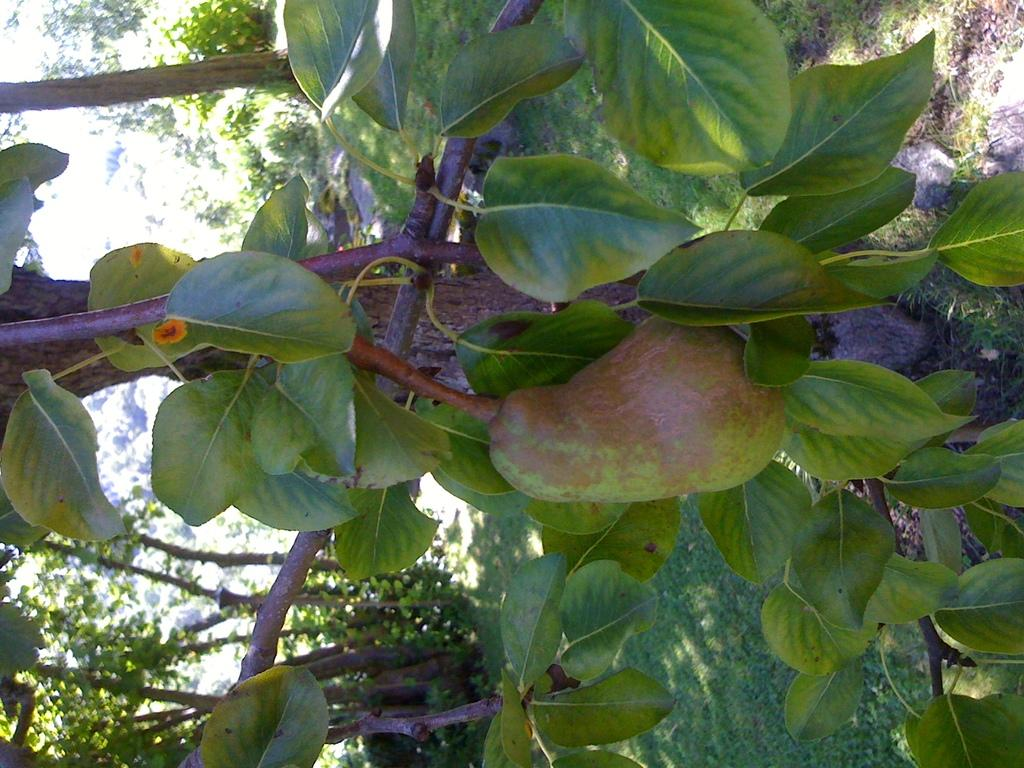What type of fruit is in the image? There is a fruit in the image, but the specific type cannot be determined from the provided facts. What can be seen in the image besides the fruit? There are green leaves, stems, a branch, and plants visible on the right side of the image. What part of the plant is the fruit attached to? The fruit is attached to a stem in the image. What is the color of the leaves in the image? The leaves in the image are green. How do the friends compare the dock in the image? There is no mention of friends or a dock in the image, so this question cannot be answered based on the provided facts. 